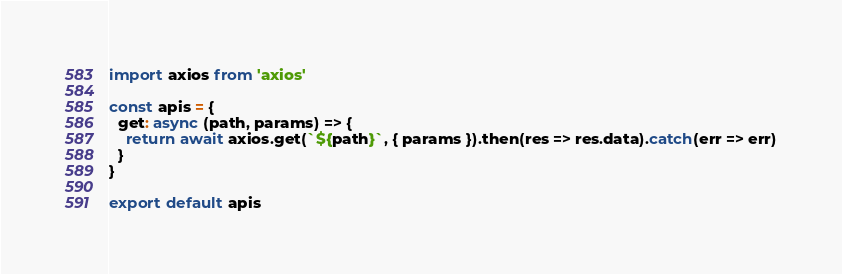Convert code to text. <code><loc_0><loc_0><loc_500><loc_500><_JavaScript_>import axios from 'axios'

const apis = {
  get: async (path, params) => {
    return await axios.get(`${path}`, { params }).then(res => res.data).catch(err => err)
  }
}

export default apis
</code> 